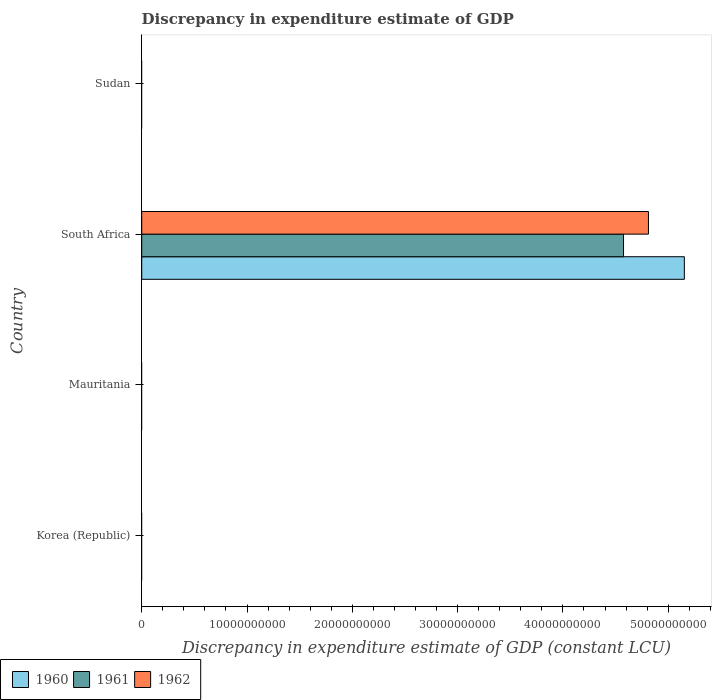Are the number of bars per tick equal to the number of legend labels?
Offer a very short reply. No. Are the number of bars on each tick of the Y-axis equal?
Ensure brevity in your answer.  No. How many bars are there on the 2nd tick from the bottom?
Your response must be concise. 0. What is the label of the 4th group of bars from the top?
Provide a short and direct response. Korea (Republic). In how many cases, is the number of bars for a given country not equal to the number of legend labels?
Offer a very short reply. 3. What is the discrepancy in expenditure estimate of GDP in 1961 in Mauritania?
Keep it short and to the point. 0. Across all countries, what is the maximum discrepancy in expenditure estimate of GDP in 1960?
Your answer should be very brief. 5.15e+1. In which country was the discrepancy in expenditure estimate of GDP in 1960 maximum?
Keep it short and to the point. South Africa. What is the total discrepancy in expenditure estimate of GDP in 1960 in the graph?
Provide a short and direct response. 5.15e+1. What is the average discrepancy in expenditure estimate of GDP in 1960 per country?
Your answer should be compact. 1.29e+1. What is the difference between the discrepancy in expenditure estimate of GDP in 1960 and discrepancy in expenditure estimate of GDP in 1961 in South Africa?
Provide a succinct answer. 5.78e+09. In how many countries, is the discrepancy in expenditure estimate of GDP in 1962 greater than 42000000000 LCU?
Your answer should be compact. 1. What is the difference between the highest and the lowest discrepancy in expenditure estimate of GDP in 1961?
Offer a very short reply. 4.58e+1. Is it the case that in every country, the sum of the discrepancy in expenditure estimate of GDP in 1960 and discrepancy in expenditure estimate of GDP in 1961 is greater than the discrepancy in expenditure estimate of GDP in 1962?
Give a very brief answer. No. How many bars are there?
Keep it short and to the point. 3. How many countries are there in the graph?
Provide a succinct answer. 4. Where does the legend appear in the graph?
Provide a succinct answer. Bottom left. What is the title of the graph?
Your answer should be compact. Discrepancy in expenditure estimate of GDP. What is the label or title of the X-axis?
Keep it short and to the point. Discrepancy in expenditure estimate of GDP (constant LCU). What is the label or title of the Y-axis?
Give a very brief answer. Country. What is the Discrepancy in expenditure estimate of GDP (constant LCU) in 1960 in Korea (Republic)?
Make the answer very short. 0. What is the Discrepancy in expenditure estimate of GDP (constant LCU) of 1962 in Korea (Republic)?
Offer a terse response. 0. What is the Discrepancy in expenditure estimate of GDP (constant LCU) in 1961 in Mauritania?
Make the answer very short. 0. What is the Discrepancy in expenditure estimate of GDP (constant LCU) of 1960 in South Africa?
Your answer should be very brief. 5.15e+1. What is the Discrepancy in expenditure estimate of GDP (constant LCU) in 1961 in South Africa?
Your answer should be very brief. 4.58e+1. What is the Discrepancy in expenditure estimate of GDP (constant LCU) in 1962 in South Africa?
Provide a short and direct response. 4.81e+1. What is the Discrepancy in expenditure estimate of GDP (constant LCU) of 1962 in Sudan?
Your response must be concise. 0. Across all countries, what is the maximum Discrepancy in expenditure estimate of GDP (constant LCU) of 1960?
Keep it short and to the point. 5.15e+1. Across all countries, what is the maximum Discrepancy in expenditure estimate of GDP (constant LCU) in 1961?
Offer a very short reply. 4.58e+1. Across all countries, what is the maximum Discrepancy in expenditure estimate of GDP (constant LCU) of 1962?
Offer a very short reply. 4.81e+1. Across all countries, what is the minimum Discrepancy in expenditure estimate of GDP (constant LCU) in 1960?
Your answer should be compact. 0. Across all countries, what is the minimum Discrepancy in expenditure estimate of GDP (constant LCU) in 1962?
Offer a very short reply. 0. What is the total Discrepancy in expenditure estimate of GDP (constant LCU) in 1960 in the graph?
Make the answer very short. 5.15e+1. What is the total Discrepancy in expenditure estimate of GDP (constant LCU) of 1961 in the graph?
Offer a very short reply. 4.58e+1. What is the total Discrepancy in expenditure estimate of GDP (constant LCU) of 1962 in the graph?
Make the answer very short. 4.81e+1. What is the average Discrepancy in expenditure estimate of GDP (constant LCU) of 1960 per country?
Your answer should be very brief. 1.29e+1. What is the average Discrepancy in expenditure estimate of GDP (constant LCU) in 1961 per country?
Your answer should be compact. 1.14e+1. What is the average Discrepancy in expenditure estimate of GDP (constant LCU) in 1962 per country?
Keep it short and to the point. 1.20e+1. What is the difference between the Discrepancy in expenditure estimate of GDP (constant LCU) in 1960 and Discrepancy in expenditure estimate of GDP (constant LCU) in 1961 in South Africa?
Make the answer very short. 5.78e+09. What is the difference between the Discrepancy in expenditure estimate of GDP (constant LCU) of 1960 and Discrepancy in expenditure estimate of GDP (constant LCU) of 1962 in South Africa?
Your response must be concise. 3.41e+09. What is the difference between the Discrepancy in expenditure estimate of GDP (constant LCU) of 1961 and Discrepancy in expenditure estimate of GDP (constant LCU) of 1962 in South Africa?
Keep it short and to the point. -2.37e+09. What is the difference between the highest and the lowest Discrepancy in expenditure estimate of GDP (constant LCU) of 1960?
Your answer should be very brief. 5.15e+1. What is the difference between the highest and the lowest Discrepancy in expenditure estimate of GDP (constant LCU) of 1961?
Provide a succinct answer. 4.58e+1. What is the difference between the highest and the lowest Discrepancy in expenditure estimate of GDP (constant LCU) in 1962?
Offer a very short reply. 4.81e+1. 